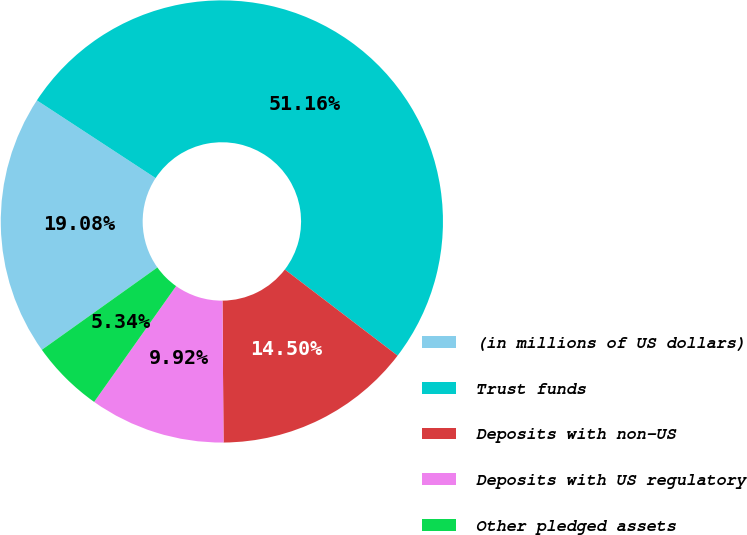<chart> <loc_0><loc_0><loc_500><loc_500><pie_chart><fcel>(in millions of US dollars)<fcel>Trust funds<fcel>Deposits with non-US<fcel>Deposits with US regulatory<fcel>Other pledged assets<nl><fcel>19.08%<fcel>51.15%<fcel>14.5%<fcel>9.92%<fcel>5.34%<nl></chart> 